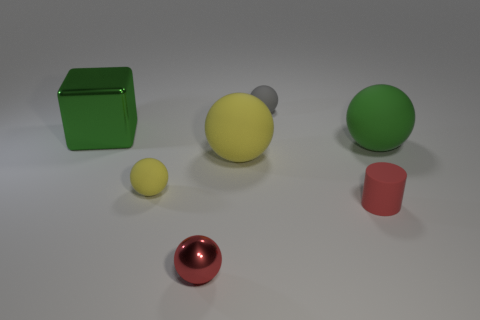The metal sphere that is the same color as the matte cylinder is what size?
Your answer should be compact. Small. Are there any other things of the same color as the rubber cylinder?
Give a very brief answer. Yes. Does the large matte object that is on the left side of the gray matte thing have the same color as the tiny matte sphere in front of the large block?
Your response must be concise. Yes. There is a red ball that is the same size as the gray ball; what is its material?
Provide a short and direct response. Metal. There is a yellow matte thing that is on the left side of the metal object that is in front of the rubber ball in front of the big yellow thing; what is its size?
Offer a very short reply. Small. What size is the object in front of the small cylinder?
Offer a very short reply. Small. There is a matte ball on the right side of the small rubber object behind the small yellow matte sphere; what is its size?
Offer a very short reply. Large. Is the number of small red metallic balls to the left of the large green shiny thing greater than the number of small purple shiny blocks?
Give a very brief answer. No. There is a yellow matte thing right of the red shiny object; does it have the same size as the tiny gray object?
Make the answer very short. No. There is a tiny ball that is both in front of the green matte object and behind the tiny rubber cylinder; what is its color?
Your answer should be very brief. Yellow. 